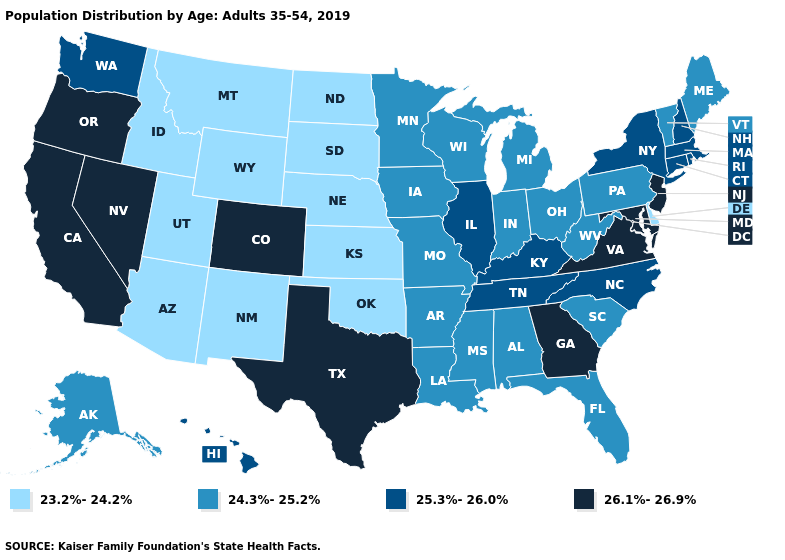Name the states that have a value in the range 25.3%-26.0%?
Keep it brief. Connecticut, Hawaii, Illinois, Kentucky, Massachusetts, New Hampshire, New York, North Carolina, Rhode Island, Tennessee, Washington. Name the states that have a value in the range 23.2%-24.2%?
Concise answer only. Arizona, Delaware, Idaho, Kansas, Montana, Nebraska, New Mexico, North Dakota, Oklahoma, South Dakota, Utah, Wyoming. Among the states that border Kansas , does Oklahoma have the lowest value?
Quick response, please. Yes. What is the value of New Mexico?
Short answer required. 23.2%-24.2%. What is the value of Rhode Island?
Quick response, please. 25.3%-26.0%. Name the states that have a value in the range 25.3%-26.0%?
Short answer required. Connecticut, Hawaii, Illinois, Kentucky, Massachusetts, New Hampshire, New York, North Carolina, Rhode Island, Tennessee, Washington. Does the first symbol in the legend represent the smallest category?
Short answer required. Yes. What is the value of South Carolina?
Short answer required. 24.3%-25.2%. Which states have the lowest value in the South?
Write a very short answer. Delaware, Oklahoma. What is the value of Pennsylvania?
Be succinct. 24.3%-25.2%. What is the value of Montana?
Be succinct. 23.2%-24.2%. Does Indiana have the same value as Arizona?
Quick response, please. No. What is the lowest value in states that border Montana?
Concise answer only. 23.2%-24.2%. Name the states that have a value in the range 23.2%-24.2%?
Keep it brief. Arizona, Delaware, Idaho, Kansas, Montana, Nebraska, New Mexico, North Dakota, Oklahoma, South Dakota, Utah, Wyoming. Among the states that border Illinois , which have the highest value?
Be succinct. Kentucky. 